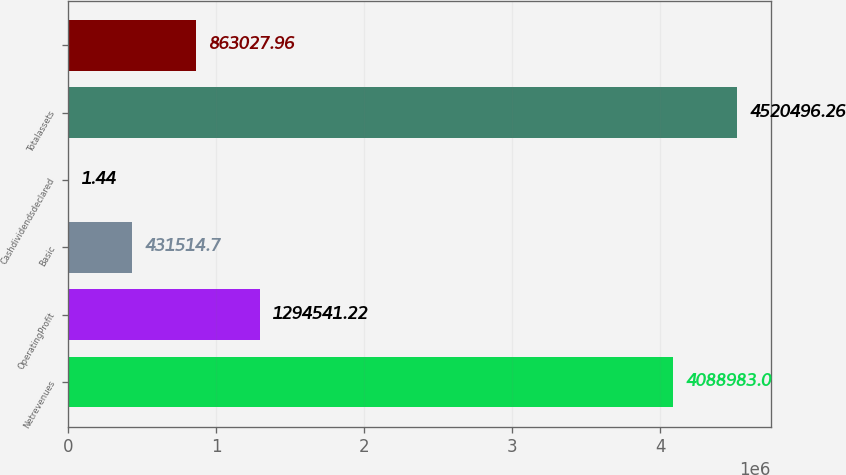<chart> <loc_0><loc_0><loc_500><loc_500><bar_chart><fcel>Netrevenues<fcel>OperatingProfit<fcel>Basic<fcel>Cashdividendsdeclared<fcel>Totalassets<fcel>Unnamed: 5<nl><fcel>4.08898e+06<fcel>1.29454e+06<fcel>431515<fcel>1.44<fcel>4.5205e+06<fcel>863028<nl></chart> 